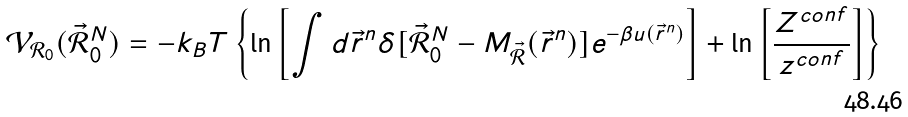Convert formula to latex. <formula><loc_0><loc_0><loc_500><loc_500>\mathcal { V } _ { \mathcal { R } _ { 0 } } ( \vec { \mathcal { R } } _ { 0 } ^ { N } ) = - k _ { B } T \left \{ \ln \left [ \int { d \vec { r } ^ { n } \delta [ \vec { \mathcal { R } } _ { 0 } ^ { N } - M _ { \vec { \mathcal { R } } } ( \vec { r } ^ { n } ) ] e ^ { - \beta u ( \vec { r } ^ { n } ) } } \right ] + \ln \left [ \frac { Z ^ { c o n f } } { z ^ { c o n f } } \right ] \right \}</formula> 